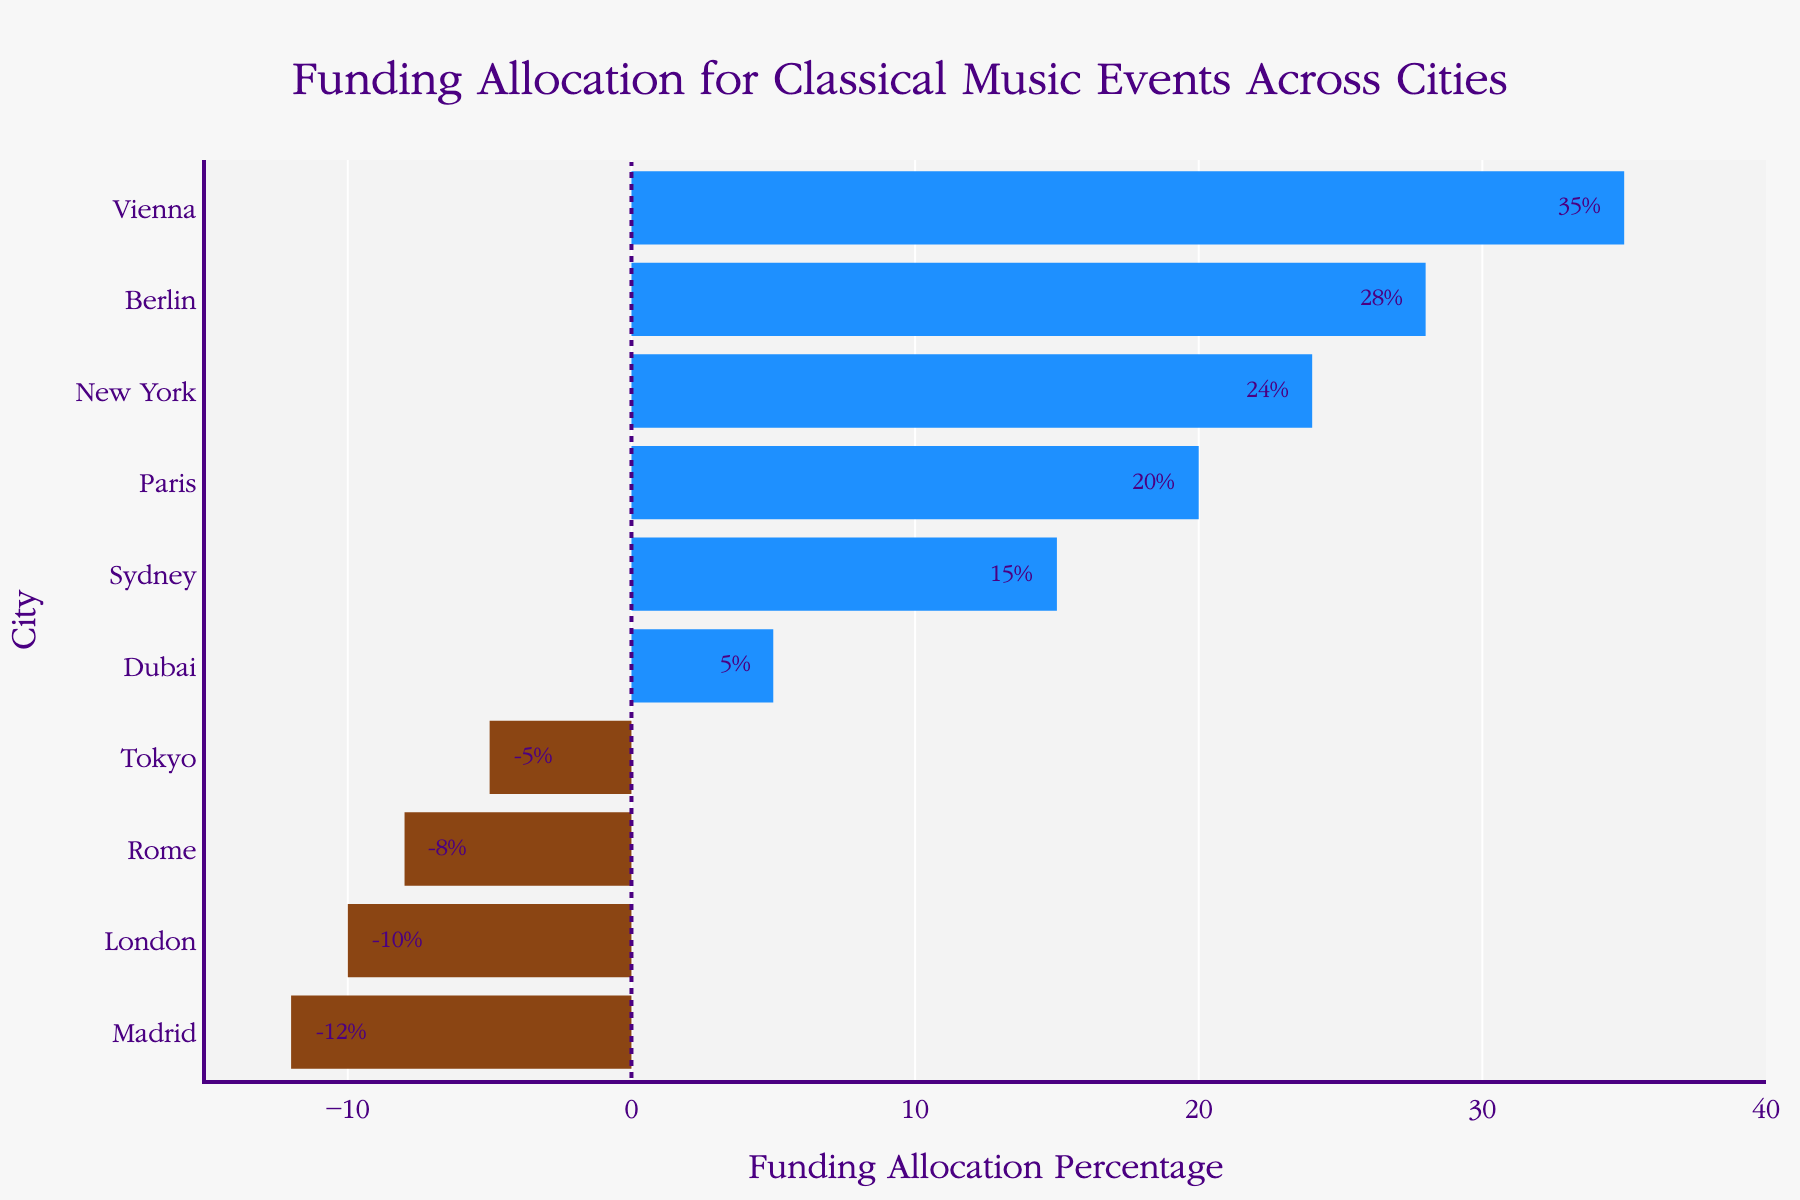What's the highest funding allocation percentage? The highest funding allocation percentage can be determined by looking for the longest bar that extends to the right of the vertical line at x=0. The longest bar belongs to Vienna with a percentage of 35%.
Answer: 35% Which city has the least funding allocation? The city with the least funding allocation has the shortest bar extending to the left of the vertical line at x=0. Madrid has the smallest bar at -12%.
Answer: Madrid How many cities have a negative funding allocation? To find this, count the cities with bars extending to the left of the vertical line at x=0. The cities are London, Tokyo, Rome, and Madrid.
Answer: 4 What is the sum of funding allocations for Vienna and Berlin? Vienna has a funding allocation of 35%, and Berlin has 28%. Adding these together gives 35% + 28% = 63%.
Answer: 63% Compare the funding allocations of New York and Paris. Which one is higher? New York has a funding allocation of 24%, and Paris has 20%. New York's allocation is higher.
Answer: New York What is the difference between the highest and lowest funding allocations? The highest funding allocation is 35% (Vienna), and the lowest is -12% (Madrid). The difference is 35% - (-12%) = 47%.
Answer: 47% What is the average funding allocation of cities with positive values? Positive funding allocations are 35% (Vienna), 20% (Paris), 24% (New York), 28% (Berlin), 15% (Sydney), and 5% (Dubai). The sum is 35 + 20 + 24 + 28 + 15 + 5 = 127. There are 6 cities, so the average is 127/6 ≈ 21.17%.
Answer: 21.17% Which cities have funding allocations greater than 10%? Cities with funding allocations greater than 10% have bars extending more than 10 units to the right of the vertical line at x=0. They are Vienna, Paris, New York, Berlin, and Sydney.
Answer: Vienna, Paris, New York, Berlin, Sydney What's the range of funding allocations across all cities? The range is determined by subtracting the lowest funding allocation from the highest. The highest is 35% (Vienna), and the lowest is -12% (Madrid). The range is 35 - (-12) = 47%.
Answer: 47% Which city has the second-highest funding allocation? The second-highest bar to the right of the vertical line at x=0 belongs to Berlin with 28%.
Answer: Berlin 